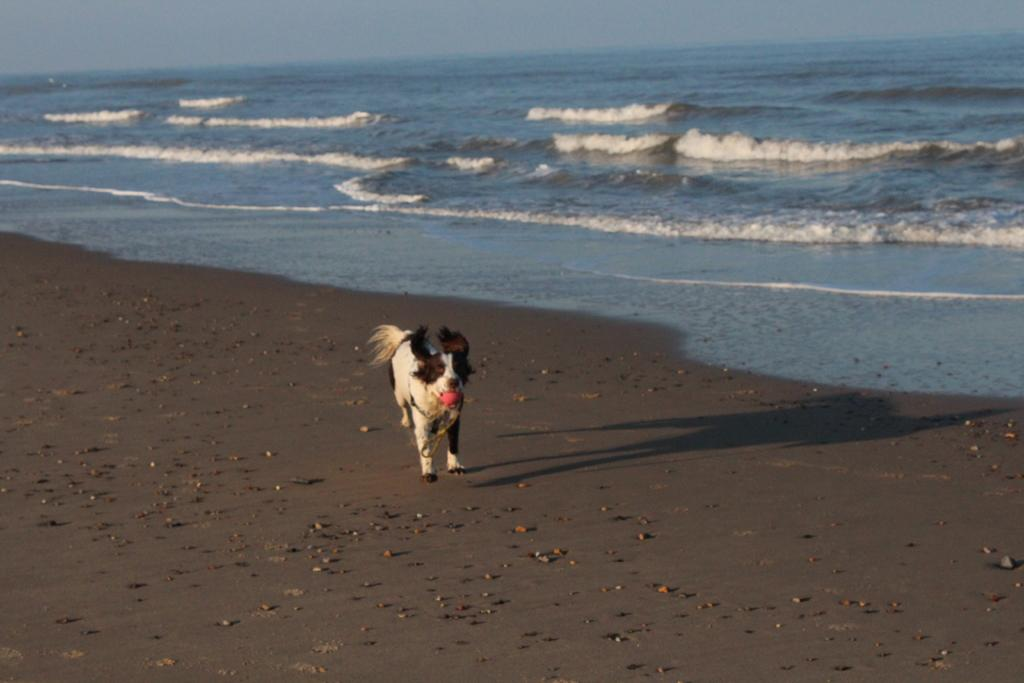What animal can be seen in the image? There is a dog in the image. Where is the dog located? The dog is on the ground. What else is visible in the image besides the dog? There is water and the sky visible in the image. How many friends does the dog have in the image? There is no indication of friends in the image, as it only features a dog on the ground. What type of work is the farmer doing in the image? There is no farmer present in the image; it only features a dog on the ground. 